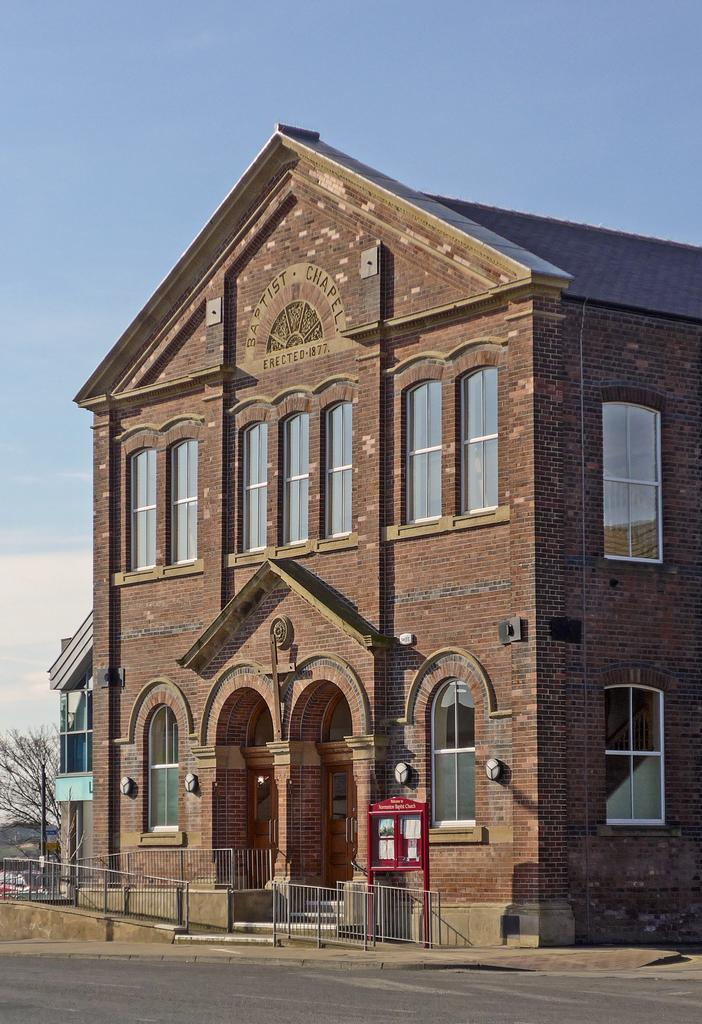What type of structure is present in the image? There is a building in the image. What is located near the building? There is a fence and a road in the image. What can be seen on the building? There are windows in the image. What is visible in the background of the image? There is a tree and the sky in the background of the image. What type of education can be seen taking place in the image? There is no indication of any educational activity in the image. 